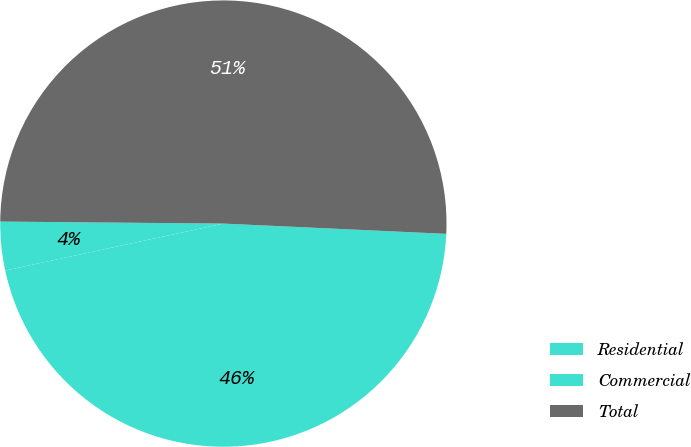Convert chart. <chart><loc_0><loc_0><loc_500><loc_500><pie_chart><fcel>Residential<fcel>Commercial<fcel>Total<nl><fcel>45.89%<fcel>3.52%<fcel>50.59%<nl></chart> 